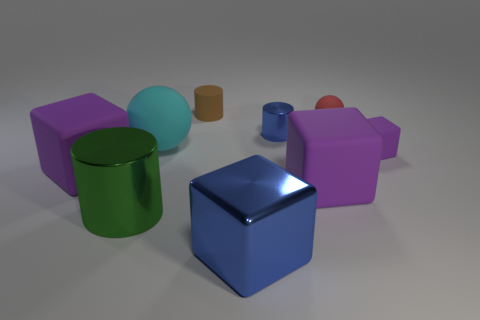Subtract all purple cubes. How many were subtracted if there are1purple cubes left? 2 Subtract all brown cylinders. How many purple cubes are left? 3 Add 1 gray blocks. How many objects exist? 10 Subtract all spheres. How many objects are left? 7 Subtract 0 yellow blocks. How many objects are left? 9 Subtract all tiny red objects. Subtract all small brown objects. How many objects are left? 7 Add 8 cyan rubber objects. How many cyan rubber objects are left? 9 Add 3 gray shiny blocks. How many gray shiny blocks exist? 3 